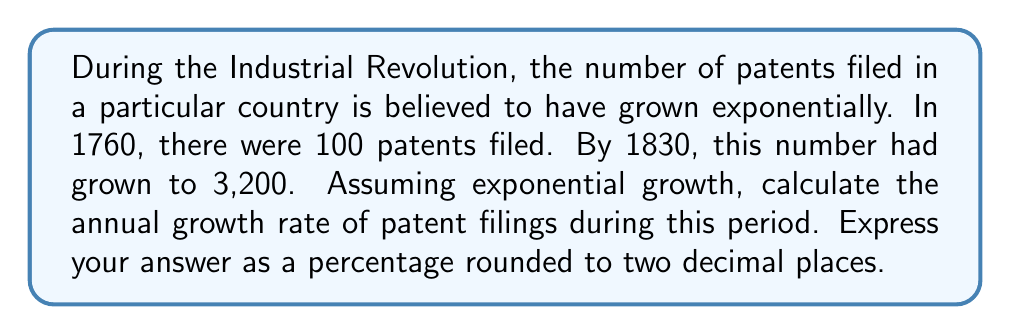Can you solve this math problem? To solve this problem, we'll use the exponential growth model:

$$A = P(1 + r)^t$$

Where:
$A$ = Final amount (3,200 patents)
$P$ = Initial amount (100 patents)
$r$ = Annual growth rate (what we're solving for)
$t$ = Time period (1830 - 1760 = 70 years)

Let's solve for $r$:

1) Plug in the known values:
   $$3200 = 100(1 + r)^{70}$$

2) Divide both sides by 100:
   $$32 = (1 + r)^{70}$$

3) Take the 70th root of both sides:
   $$\sqrt[70]{32} = 1 + r$$

4) Subtract 1 from both sides:
   $$\sqrt[70]{32} - 1 = r$$

5) Calculate:
   $$r \approx 1.0495 - 1 = 0.0495$$

6) Convert to a percentage:
   $$0.0495 \times 100 = 4.95\%$$

This represents the annual growth rate of patent filings, which can be interpreted as a measure of the rate of technological innovation during this period of the Industrial Revolution.
Answer: 4.95% 